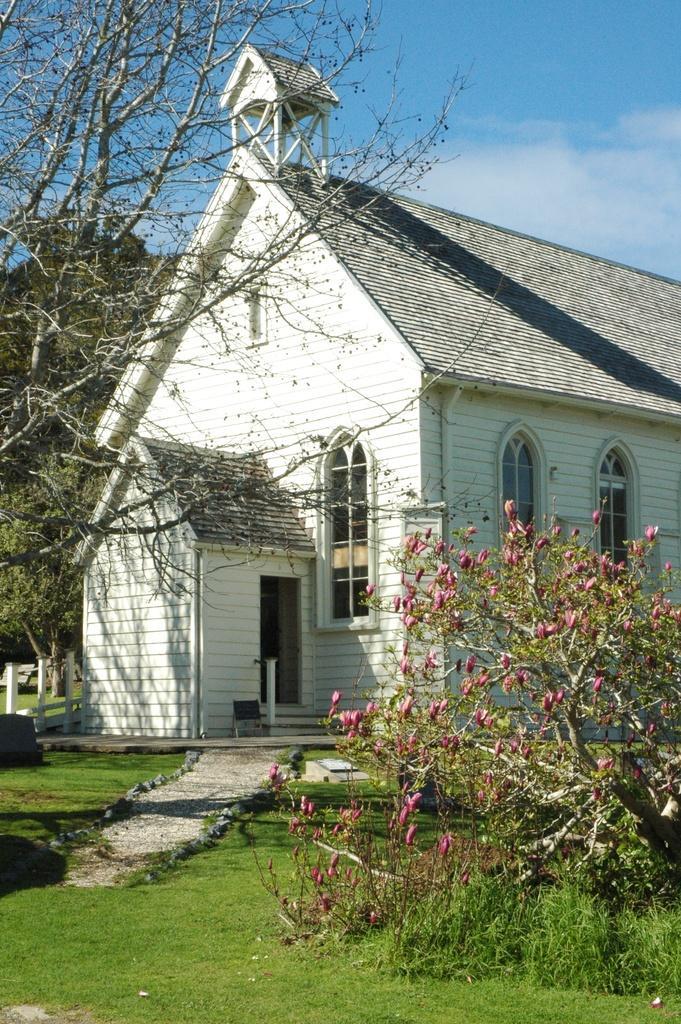Can you describe this image briefly? At the bottom of the picture, we see the grass and a plant which has flowers. These flowers are in pink color. On the left side, we see the trees and the railing. In the middle of the picture, we see a building in white color with a grey color roof. There are trees in the background. At the top, we see the sky. 